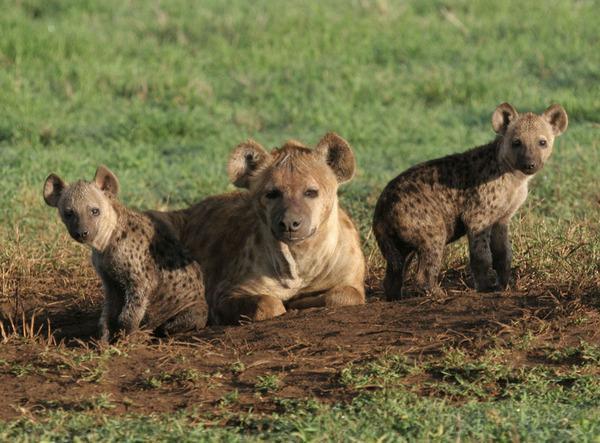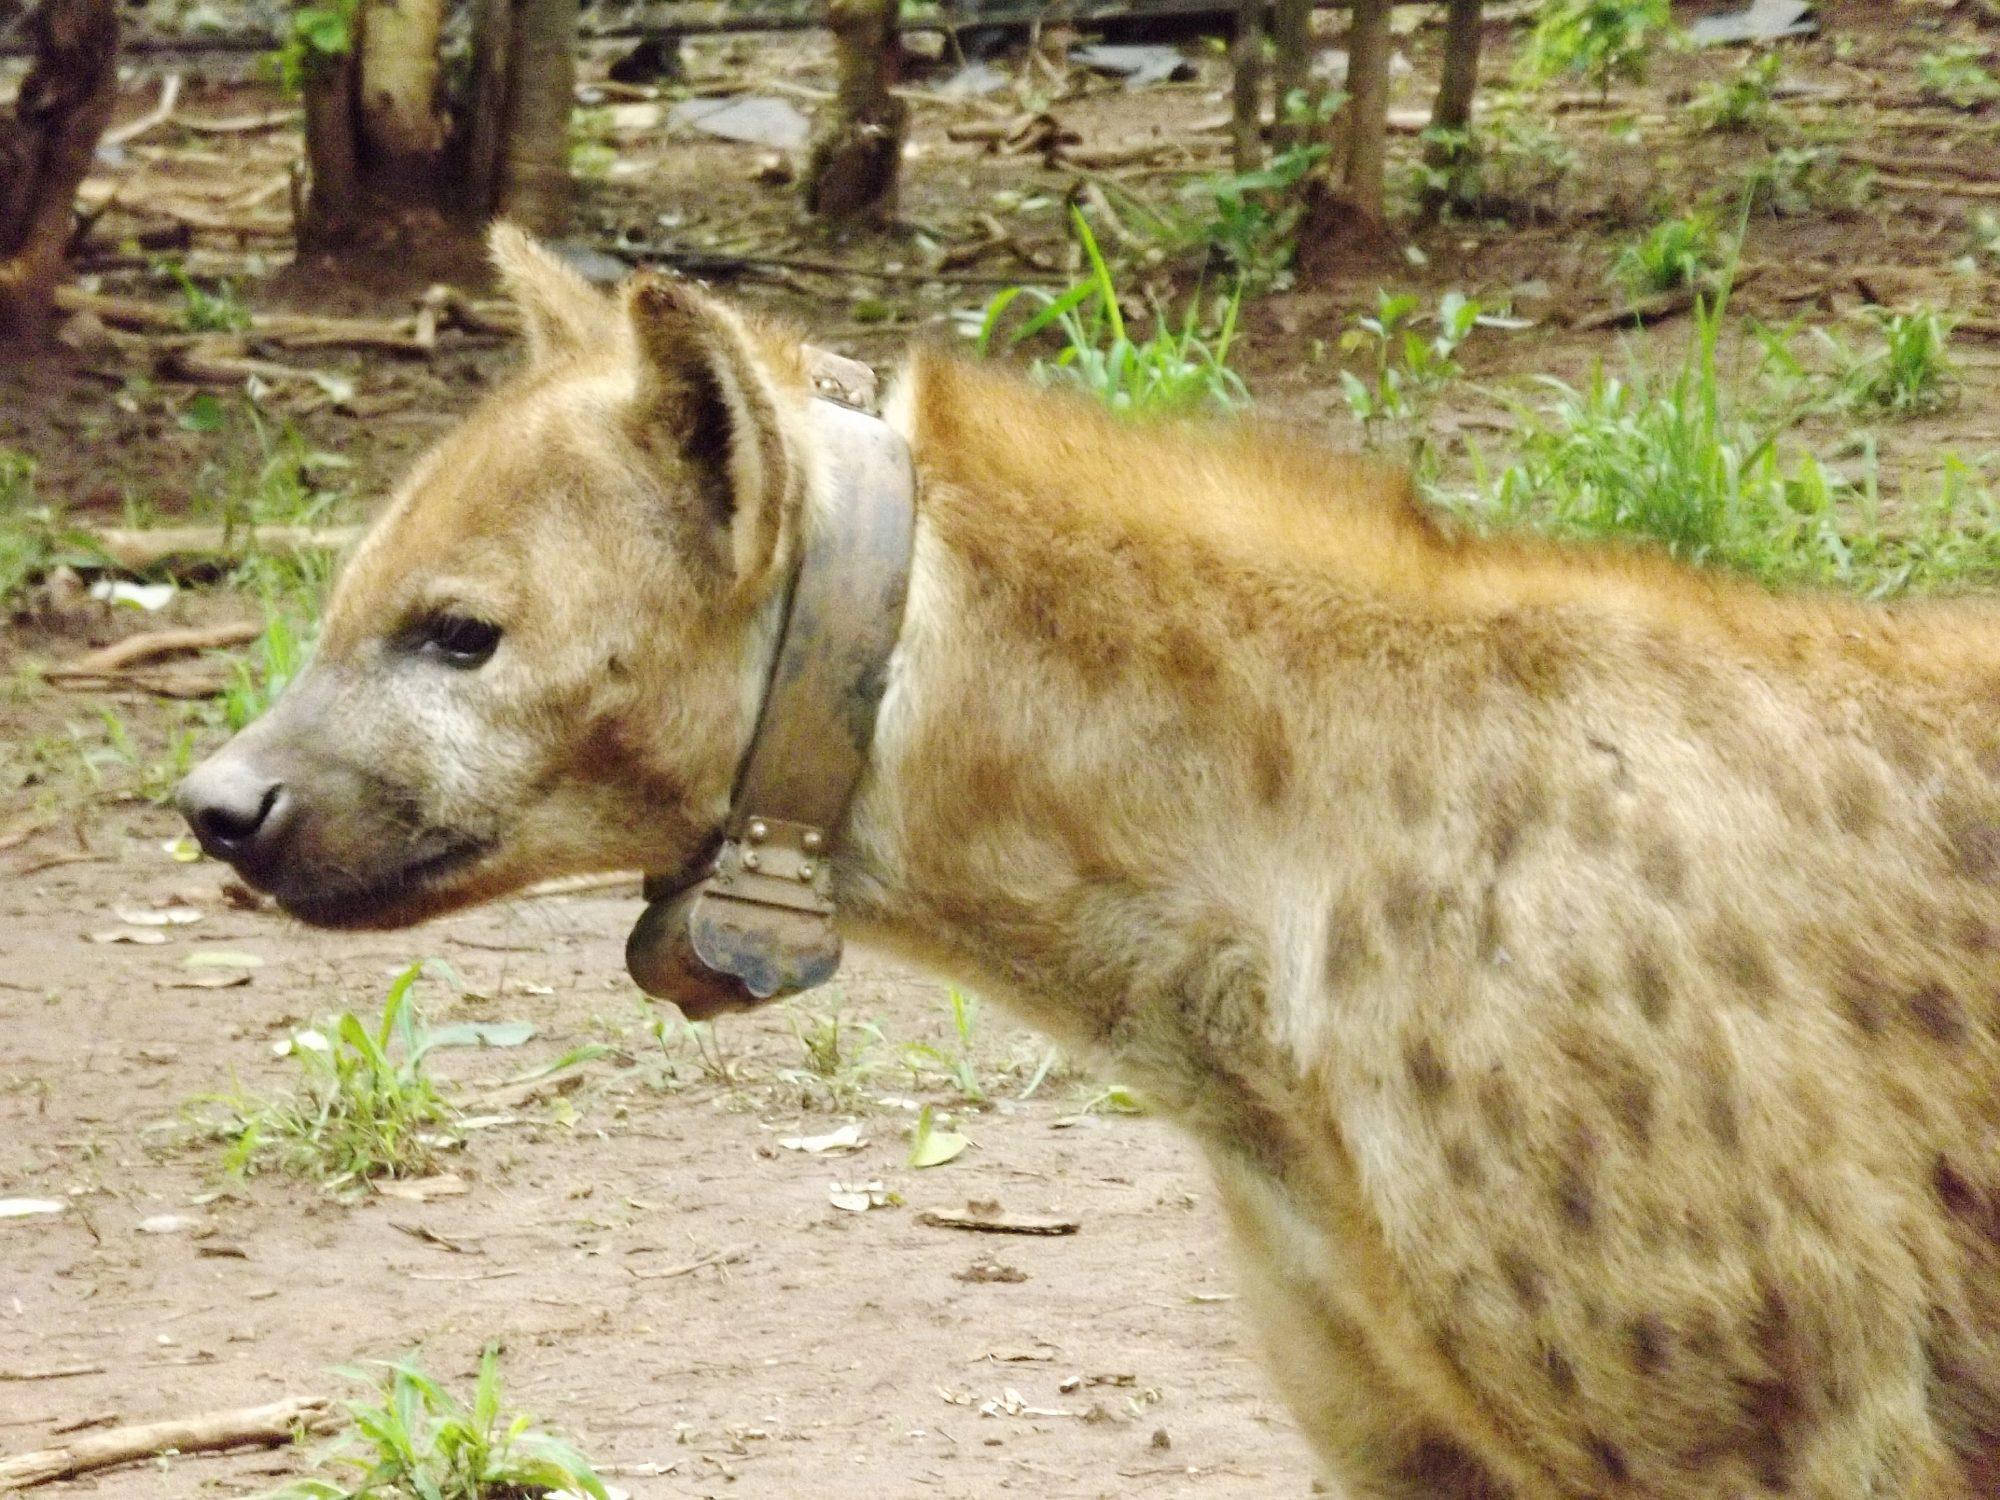The first image is the image on the left, the second image is the image on the right. Analyze the images presented: Is the assertion "there are at least two hyenas in the image on the left" valid? Answer yes or no. Yes. The first image is the image on the left, the second image is the image on the right. For the images shown, is this caption "An image shows a wild dog with its meal of prey." true? Answer yes or no. No. 